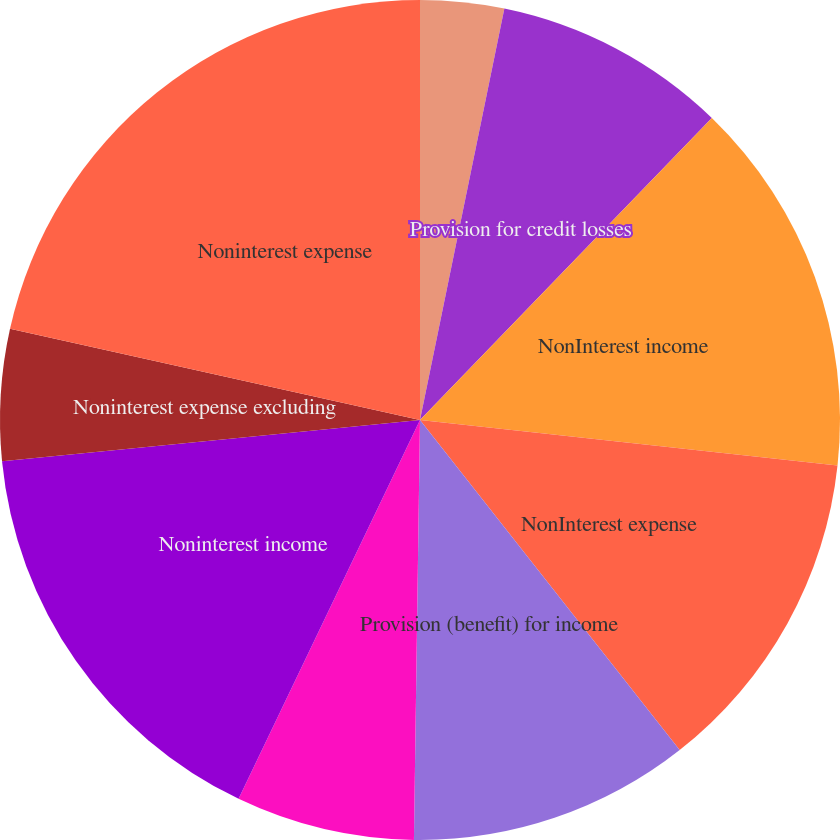Convert chart. <chart><loc_0><loc_0><loc_500><loc_500><pie_chart><fcel>Net interest income<fcel>Provision for credit losses<fcel>NonInterest income<fcel>NonInterest expense<fcel>Provision (benefit) for income<fcel>Operating/reported net income<fcel>Noninterest income<fcel>Noninterest expense excluding<fcel>Noninterest expense<nl><fcel>3.22%<fcel>9.01%<fcel>14.5%<fcel>12.67%<fcel>10.84%<fcel>6.88%<fcel>16.33%<fcel>5.05%<fcel>21.52%<nl></chart> 